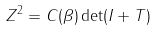<formula> <loc_0><loc_0><loc_500><loc_500>Z ^ { 2 } = C ( \beta ) \det ( I + T )</formula> 